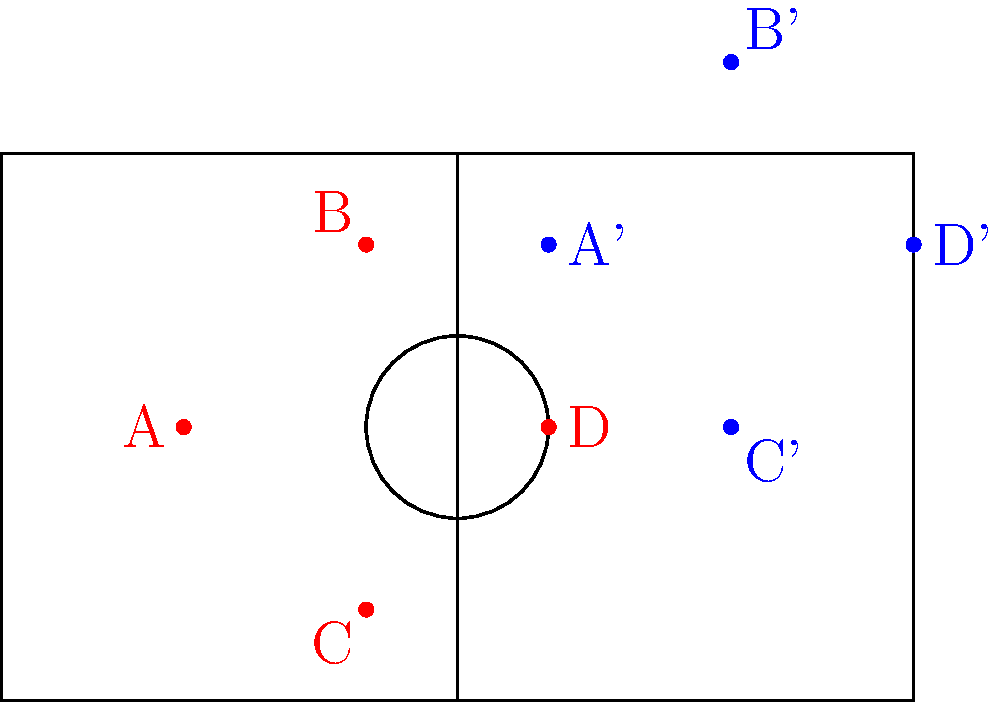In a tactical formation diagram, the red dots represent the initial positions of four players (A, B, C, and D) on a soccer field. After a translation, their new positions are represented by the blue dots (A', B', C', and D'). What is the translation vector $\vec{v}$ that moves all players from their initial to final positions? To find the translation vector $\vec{v}$, we need to follow these steps:

1. Choose any pair of corresponding points (initial and final positions of the same player).
2. Calculate the displacement vector between these points.

Let's use player A for our calculation:

1. Initial position of A: $(-3, 0)$
2. Final position of A': $(1, 2)$

The displacement vector $\vec{v}$ is the difference between the final and initial positions:

$\vec{v} = (x_{A'} - x_A, y_{A'} - y_A)$
$\vec{v} = (1 - (-3), 2 - 0)$
$\vec{v} = (4, 2)$

To verify, we can check if this vector works for the other players:

For B: $(-1, 2) + (4, 2) = (3, 4)$ (matches B')
For C: $(-1, -2) + (4, 2) = (3, 0)$ (matches C')
For D: $(1, 0) + (4, 2) = (5, 2)$ (matches D')

Therefore, the translation vector $\vec{v} = (4, 2)$ moves all players from their initial to final positions.
Answer: $\vec{v} = (4, 2)$ 